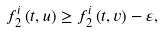<formula> <loc_0><loc_0><loc_500><loc_500>f _ { 2 } ^ { i } \left ( t , u \right ) \geq f _ { 2 } ^ { i } \left ( t , v \right ) - \varepsilon ,</formula> 